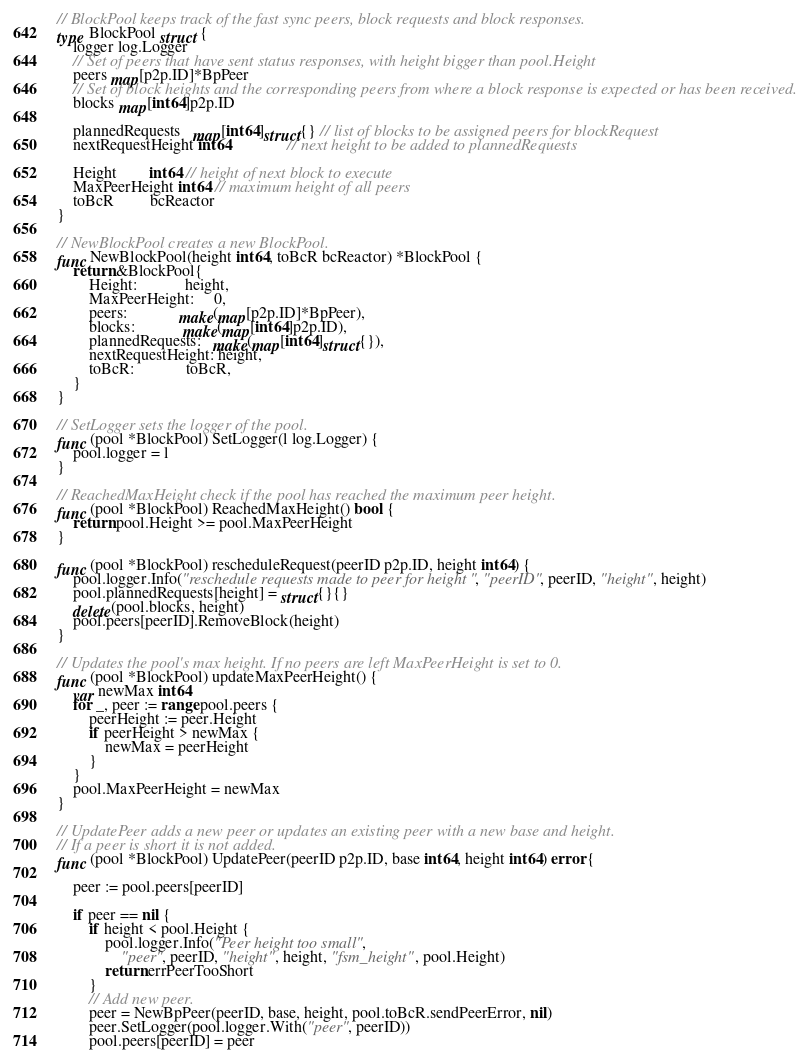<code> <loc_0><loc_0><loc_500><loc_500><_Go_>
// BlockPool keeps track of the fast sync peers, block requests and block responses.
type BlockPool struct {
	logger log.Logger
	// Set of peers that have sent status responses, with height bigger than pool.Height
	peers map[p2p.ID]*BpPeer
	// Set of block heights and the corresponding peers from where a block response is expected or has been received.
	blocks map[int64]p2p.ID

	plannedRequests   map[int64]struct{} // list of blocks to be assigned peers for blockRequest
	nextRequestHeight int64              // next height to be added to plannedRequests

	Height        int64 // height of next block to execute
	MaxPeerHeight int64 // maximum height of all peers
	toBcR         bcReactor
}

// NewBlockPool creates a new BlockPool.
func NewBlockPool(height int64, toBcR bcReactor) *BlockPool {
	return &BlockPool{
		Height:            height,
		MaxPeerHeight:     0,
		peers:             make(map[p2p.ID]*BpPeer),
		blocks:            make(map[int64]p2p.ID),
		plannedRequests:   make(map[int64]struct{}),
		nextRequestHeight: height,
		toBcR:             toBcR,
	}
}

// SetLogger sets the logger of the pool.
func (pool *BlockPool) SetLogger(l log.Logger) {
	pool.logger = l
}

// ReachedMaxHeight check if the pool has reached the maximum peer height.
func (pool *BlockPool) ReachedMaxHeight() bool {
	return pool.Height >= pool.MaxPeerHeight
}

func (pool *BlockPool) rescheduleRequest(peerID p2p.ID, height int64) {
	pool.logger.Info("reschedule requests made to peer for height ", "peerID", peerID, "height", height)
	pool.plannedRequests[height] = struct{}{}
	delete(pool.blocks, height)
	pool.peers[peerID].RemoveBlock(height)
}

// Updates the pool's max height. If no peers are left MaxPeerHeight is set to 0.
func (pool *BlockPool) updateMaxPeerHeight() {
	var newMax int64
	for _, peer := range pool.peers {
		peerHeight := peer.Height
		if peerHeight > newMax {
			newMax = peerHeight
		}
	}
	pool.MaxPeerHeight = newMax
}

// UpdatePeer adds a new peer or updates an existing peer with a new base and height.
// If a peer is short it is not added.
func (pool *BlockPool) UpdatePeer(peerID p2p.ID, base int64, height int64) error {

	peer := pool.peers[peerID]

	if peer == nil {
		if height < pool.Height {
			pool.logger.Info("Peer height too small",
				"peer", peerID, "height", height, "fsm_height", pool.Height)
			return errPeerTooShort
		}
		// Add new peer.
		peer = NewBpPeer(peerID, base, height, pool.toBcR.sendPeerError, nil)
		peer.SetLogger(pool.logger.With("peer", peerID))
		pool.peers[peerID] = peer</code> 